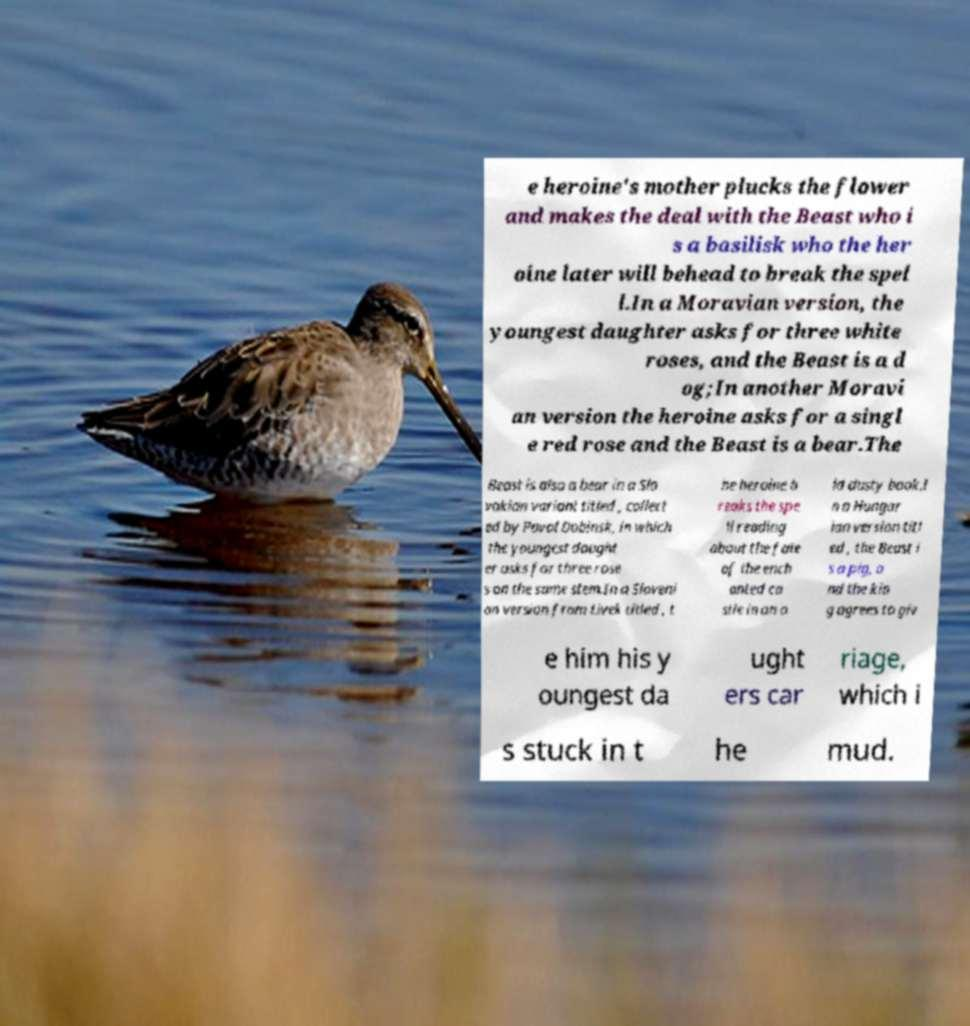Can you accurately transcribe the text from the provided image for me? e heroine's mother plucks the flower and makes the deal with the Beast who i s a basilisk who the her oine later will behead to break the spel l.In a Moravian version, the youngest daughter asks for three white roses, and the Beast is a d og;In another Moravi an version the heroine asks for a singl e red rose and the Beast is a bear.The Beast is also a bear in a Slo vakian variant titled , collect ed by Pavol Dobinsk, in which the youngest daught er asks for three rose s on the same stem.In a Sloveni an version from Livek titled , t he heroine b reaks the spe ll reading about the fate of the ench anted ca stle in an o ld dusty book.I n a Hungar ian version titl ed , the Beast i s a pig, a nd the kin g agrees to giv e him his y oungest da ught ers car riage, which i s stuck in t he mud. 